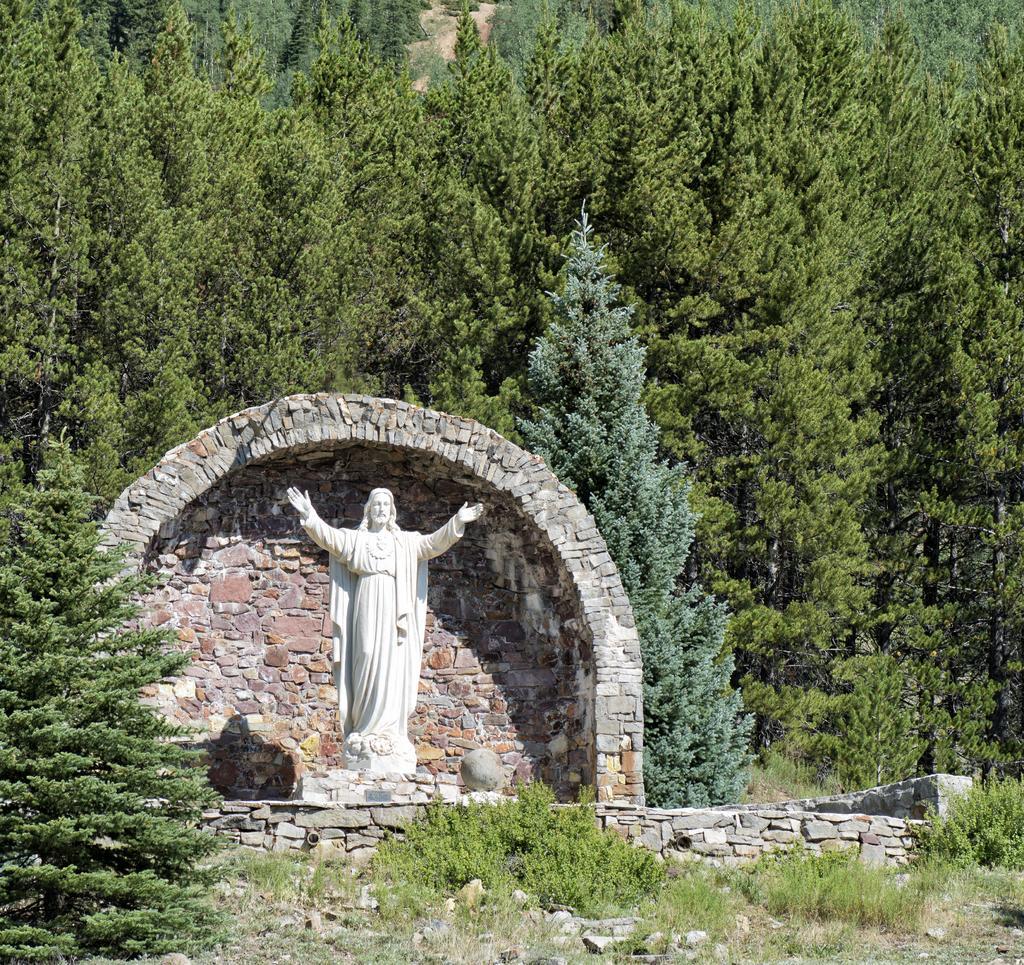In one or two sentences, can you explain what this image depicts? In the foreground of the picture there are plants, stones, trees, brick wall and a sculpture. In the background there are trees. 